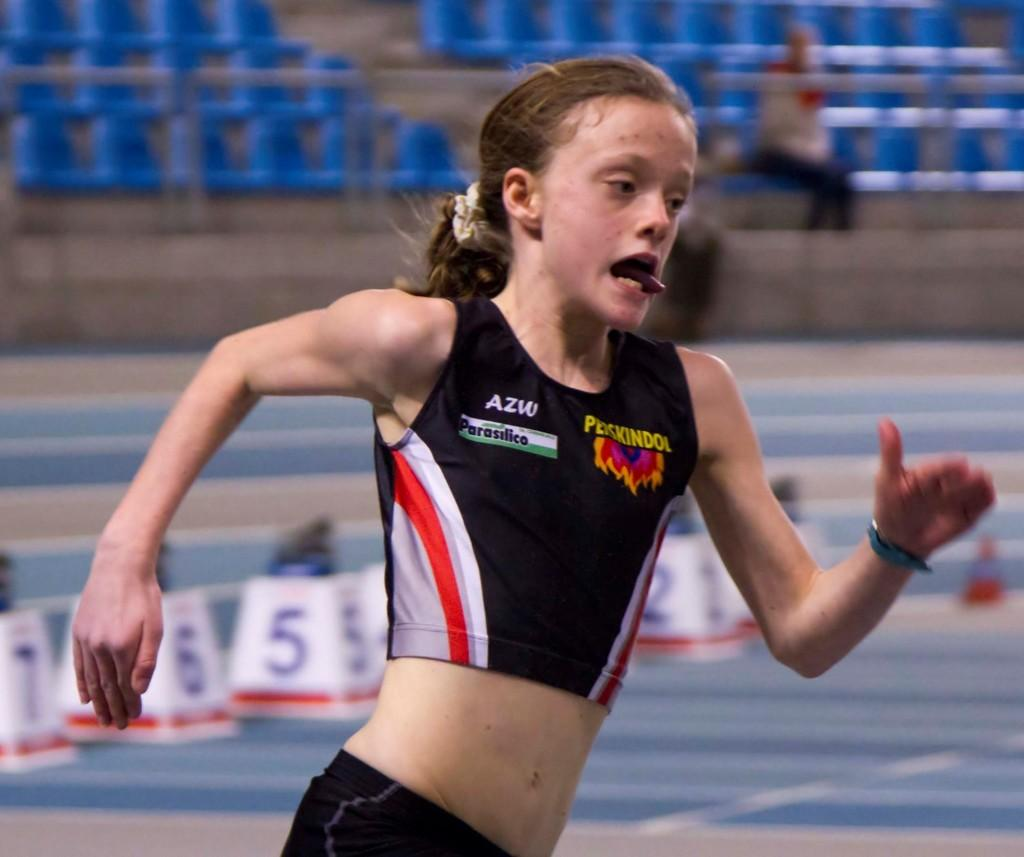<image>
Write a terse but informative summary of the picture. the girl's top has words AZW and Parasilico on it 